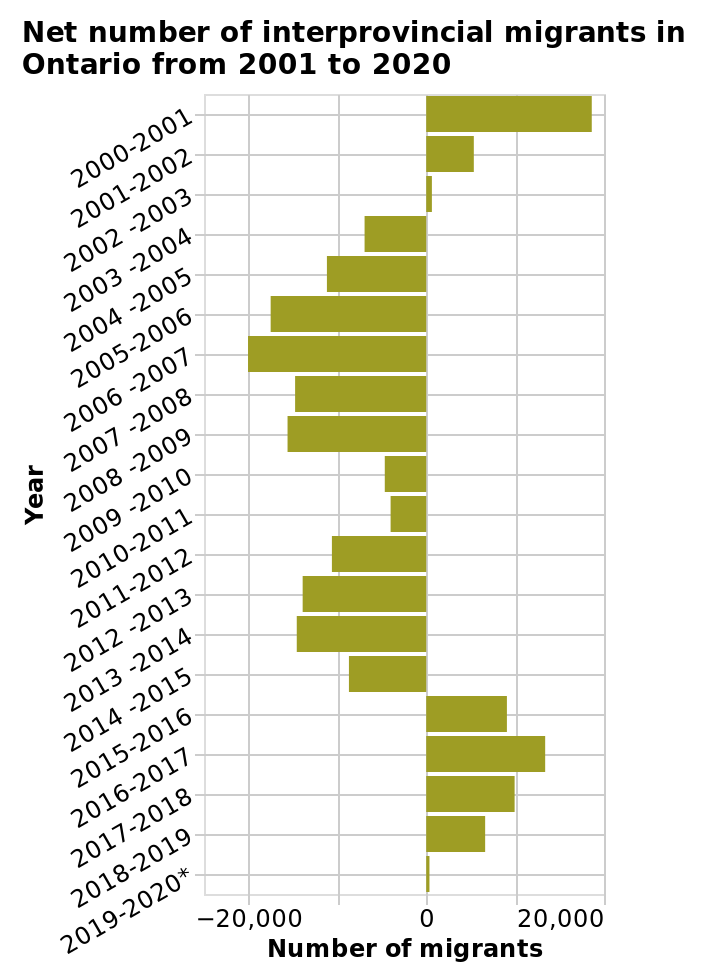<image>
When was the largest number of interprovincial migrants in Ontario? Between 2000-2001. What is the name of the bar plot?  The bar plot is named "Net number of interprovincial migrants in Ontario from 2001 to 2020." please summary the statistics and relations of the chart interprovincial migrants In Ontario was at its largest figure between 2000-2001. please describe the details of the chart Here a bar plot is named Net number of interprovincial migrants in Ontario from 2001 to 2020. A categorical scale starting at −20,000 and ending at 20,000 can be found along the x-axis, labeled Number of migrants. There is a categorical scale starting at 2000-2001 and ending at 2019-2020* on the y-axis, labeled Year. What is the range of the categorical scale on the y-axis?  The categorical scale on the y-axis ranges from 2000-2001 to 2019-2020. 